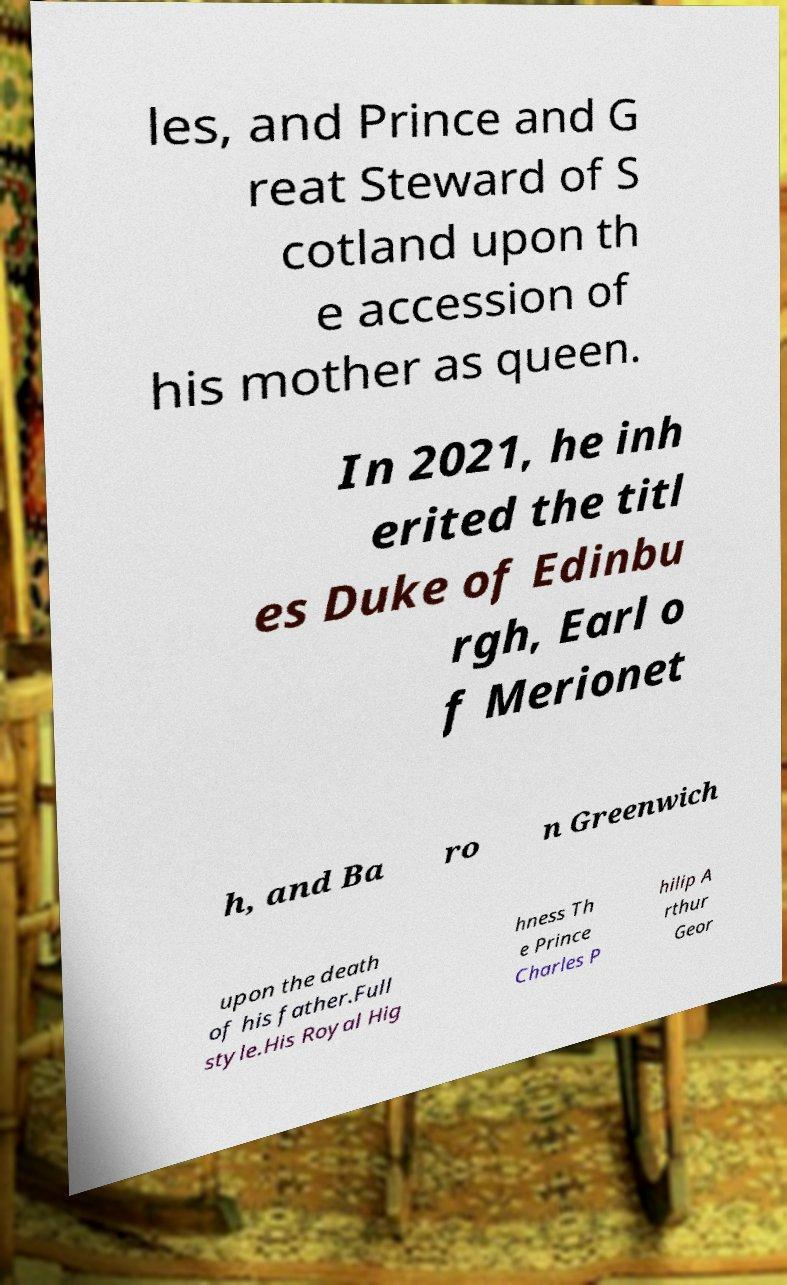Please read and relay the text visible in this image. What does it say? les, and Prince and G reat Steward of S cotland upon th e accession of his mother as queen. In 2021, he inh erited the titl es Duke of Edinbu rgh, Earl o f Merionet h, and Ba ro n Greenwich upon the death of his father.Full style.His Royal Hig hness Th e Prince Charles P hilip A rthur Geor 